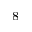Convert formula to latex. <formula><loc_0><loc_0><loc_500><loc_500>^ { 8 }</formula> 